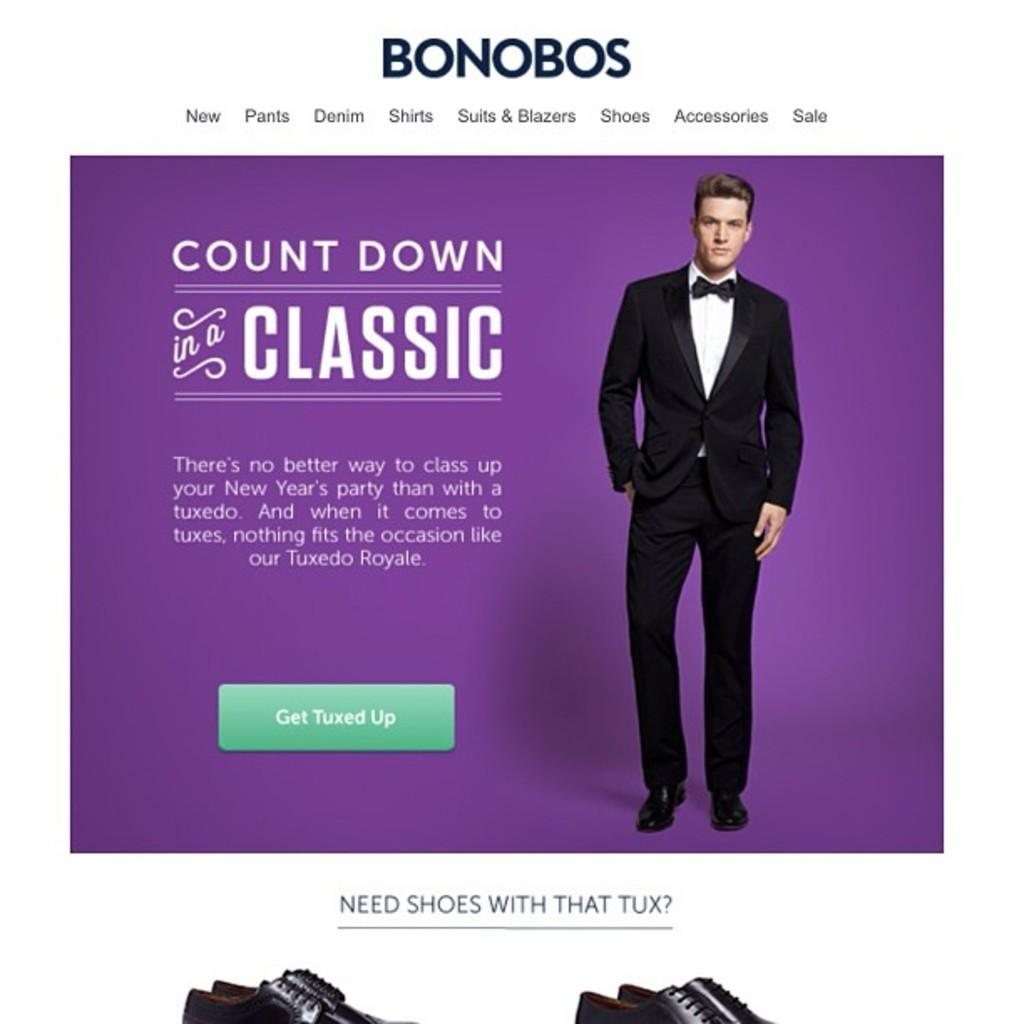What is the main subject of the image? The main subject of the image is an advertisement. What is the man in the advertisement doing? The advertisement features a man standing. What is the man wearing? The man is wearing a black suit. How many pairs of shoes can be seen in the image? There are two pairs of shoes in the image. What is written on the advertisement? There is text written on the advertisement. How does the man in the advertisement wash his car? The image does not show the man washing his car; it only features an advertisement with a man standing in a black suit. 